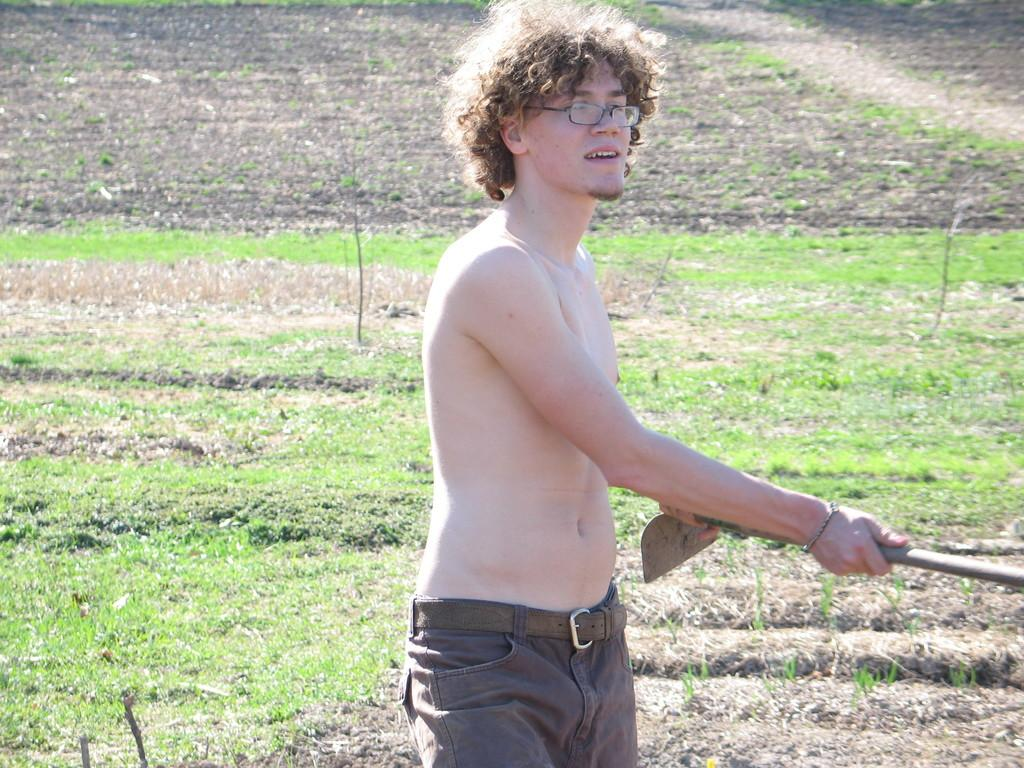What can be seen in the image? There is a person in the image. What is the person holding in their hand? The person is holding an object in their hand. What type of surface is visible at the bottom of the image? There is grass at the bottom of the image. Can you see a tiger walking through the grass in the image? No, there is no tiger present in the image. 